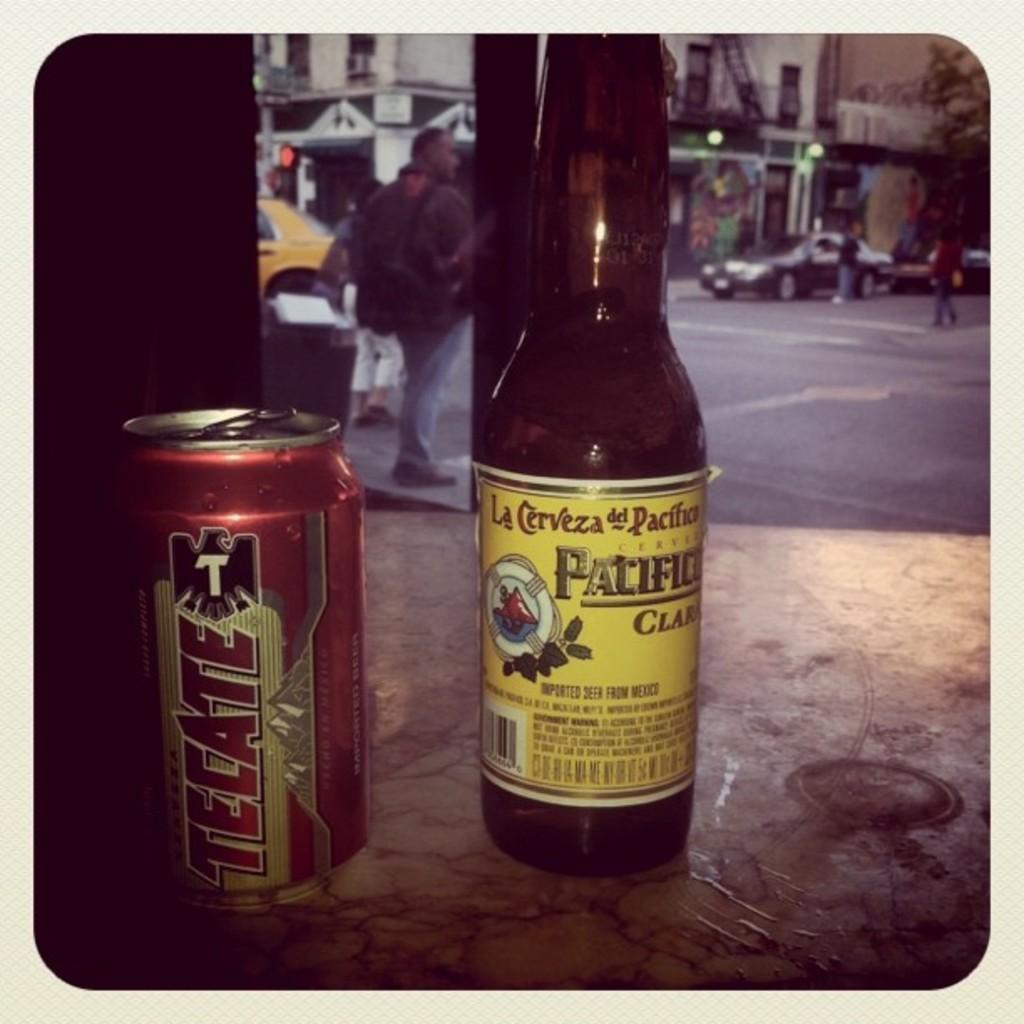<image>
Create a compact narrative representing the image presented. A can of Tecate beer next to a bottle of Pacifico 